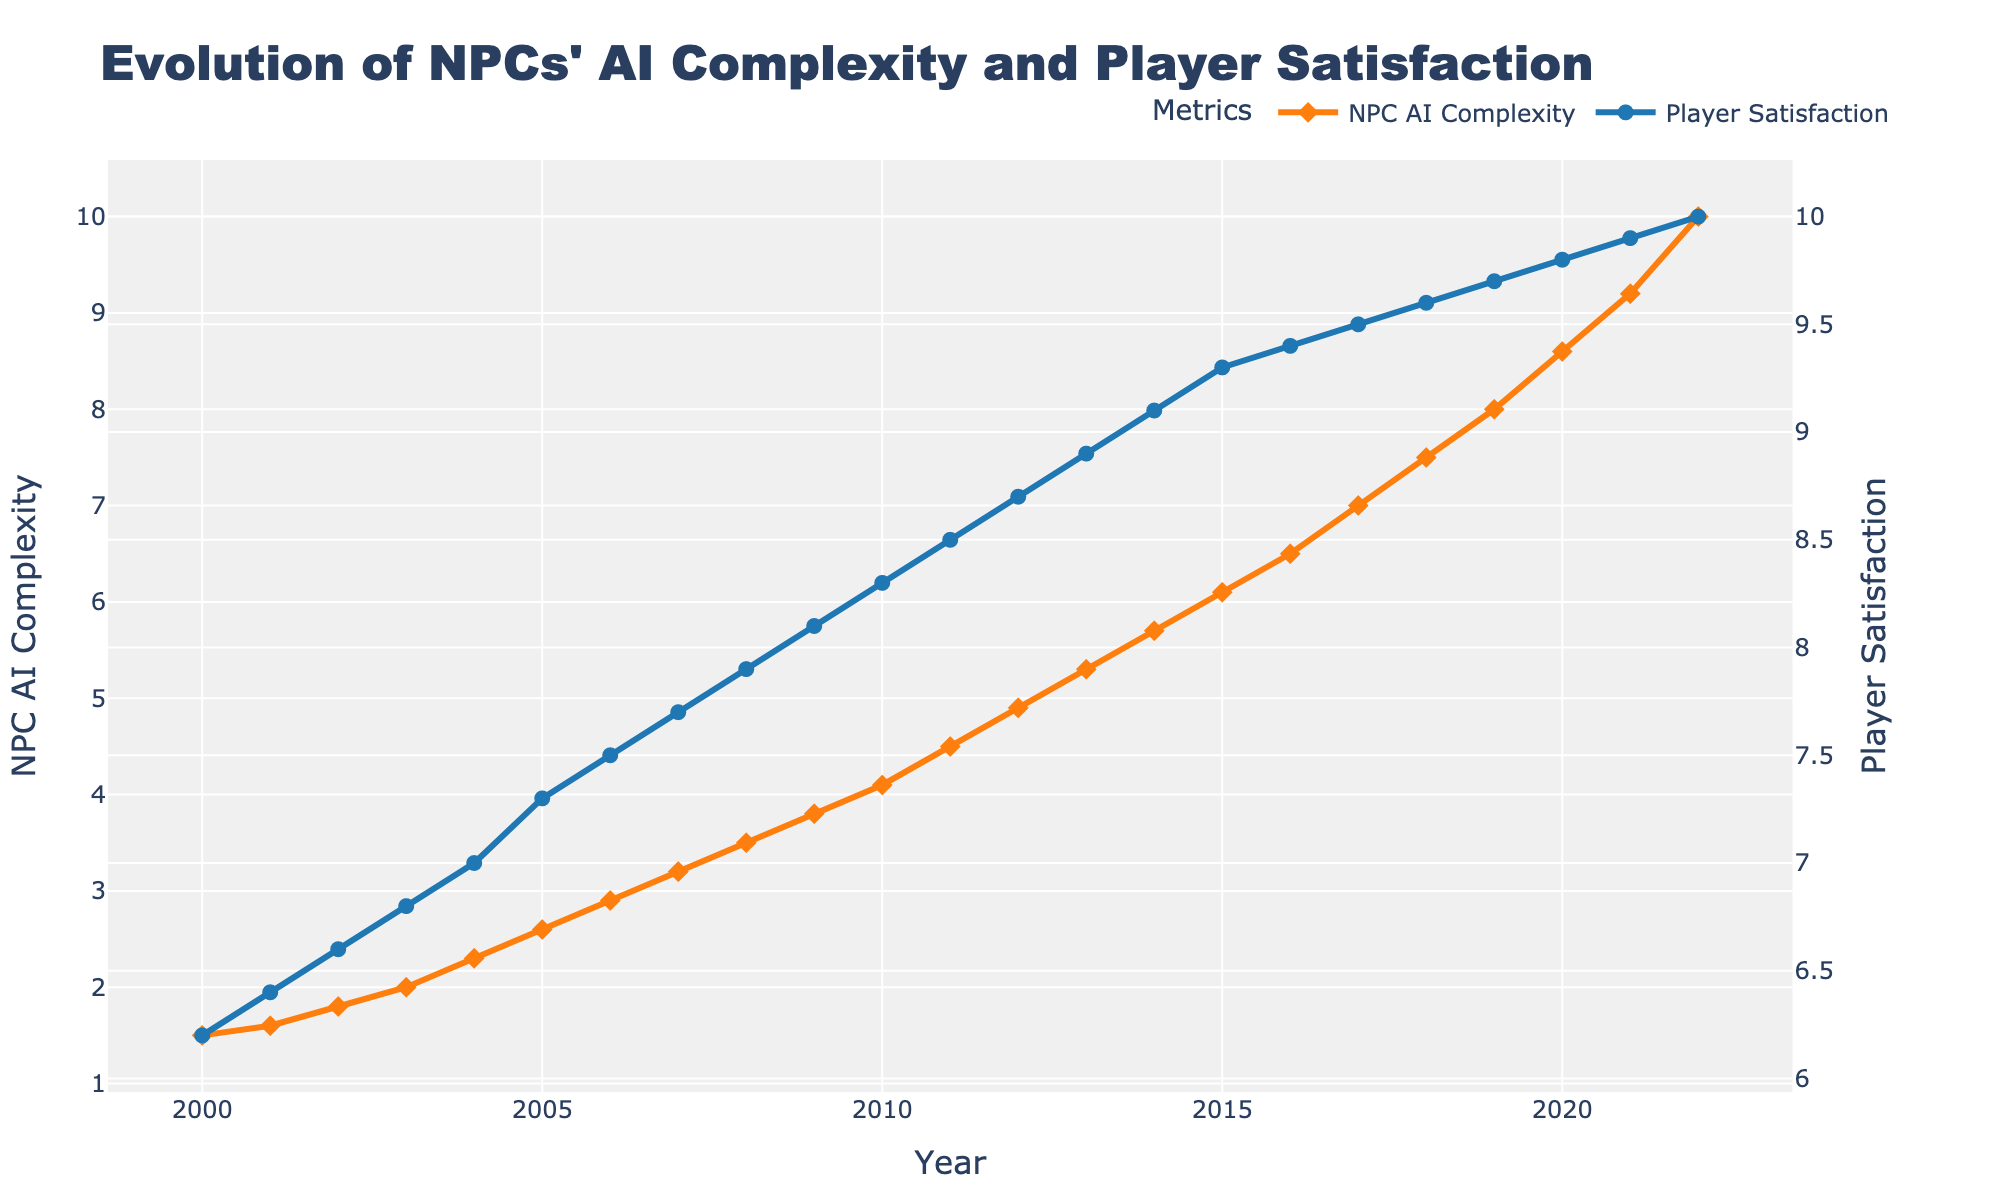What are the y-axis titles? The y-axis titles are labeled on the plot. The left y-axis is titled "NPC AI Complexity" and the right y-axis is titled "Player Satisfaction".
Answer: "NPC AI Complexity" and "Player Satisfaction" What is the highest Player Satisfaction level recorded and in which year did it occur? The highest Player Satisfaction level is 10, and it occurred in the year 2022, as indicated at the end of the Player Satisfaction line.
Answer: 10 in 2022 Around which year did NPC AI Complexity first exceed a value of 5? Examine the NPC AI Complexity line. It first exceeds a value of 5 around 2013.
Answer: Around 2013 Compare the NPC AI Complexity in 2010 and 2015. How much did it increase? In 2010, NPC AI Complexity is 4.1, and in 2015, it is 6.1. The increase is calculated as 6.1 - 4.1.
Answer: 2.0 Did the Player Satisfaction ever decrease over the years from 2000 to 2022? By observing the Player Satisfaction line, you can see it consistently increases from 6.2 in 2000 to 10 in 2022. It never decreases.
Answer: No What is the average NPC AI Complexity from 2000 to 2022? Adding up all the NPC AI Complexity values from 2000 to 2022 and dividing by the number of years (23) gives the average. Sum = 124.4, average = 124.4 / 23.
Answer: Approximately 5.41 Which year shows the largest increase in Player Satisfaction level compared to the previous year? By examining the differences year-to-year, the largest increase happens between 2021 (9.9) and 2022 (10), which is an increase of 0.1.
Answer: 2022 At what rate did NPC AI Complexity and Player Satisfaction generally change over time? NPC AI Complexity and Player Satisfaction both show a general upward trend over time. NPC AI Complexity shows a steady increase, while Player Satisfaction shows a similarly steady and proportional increase.
Answer: Steady increase for both 